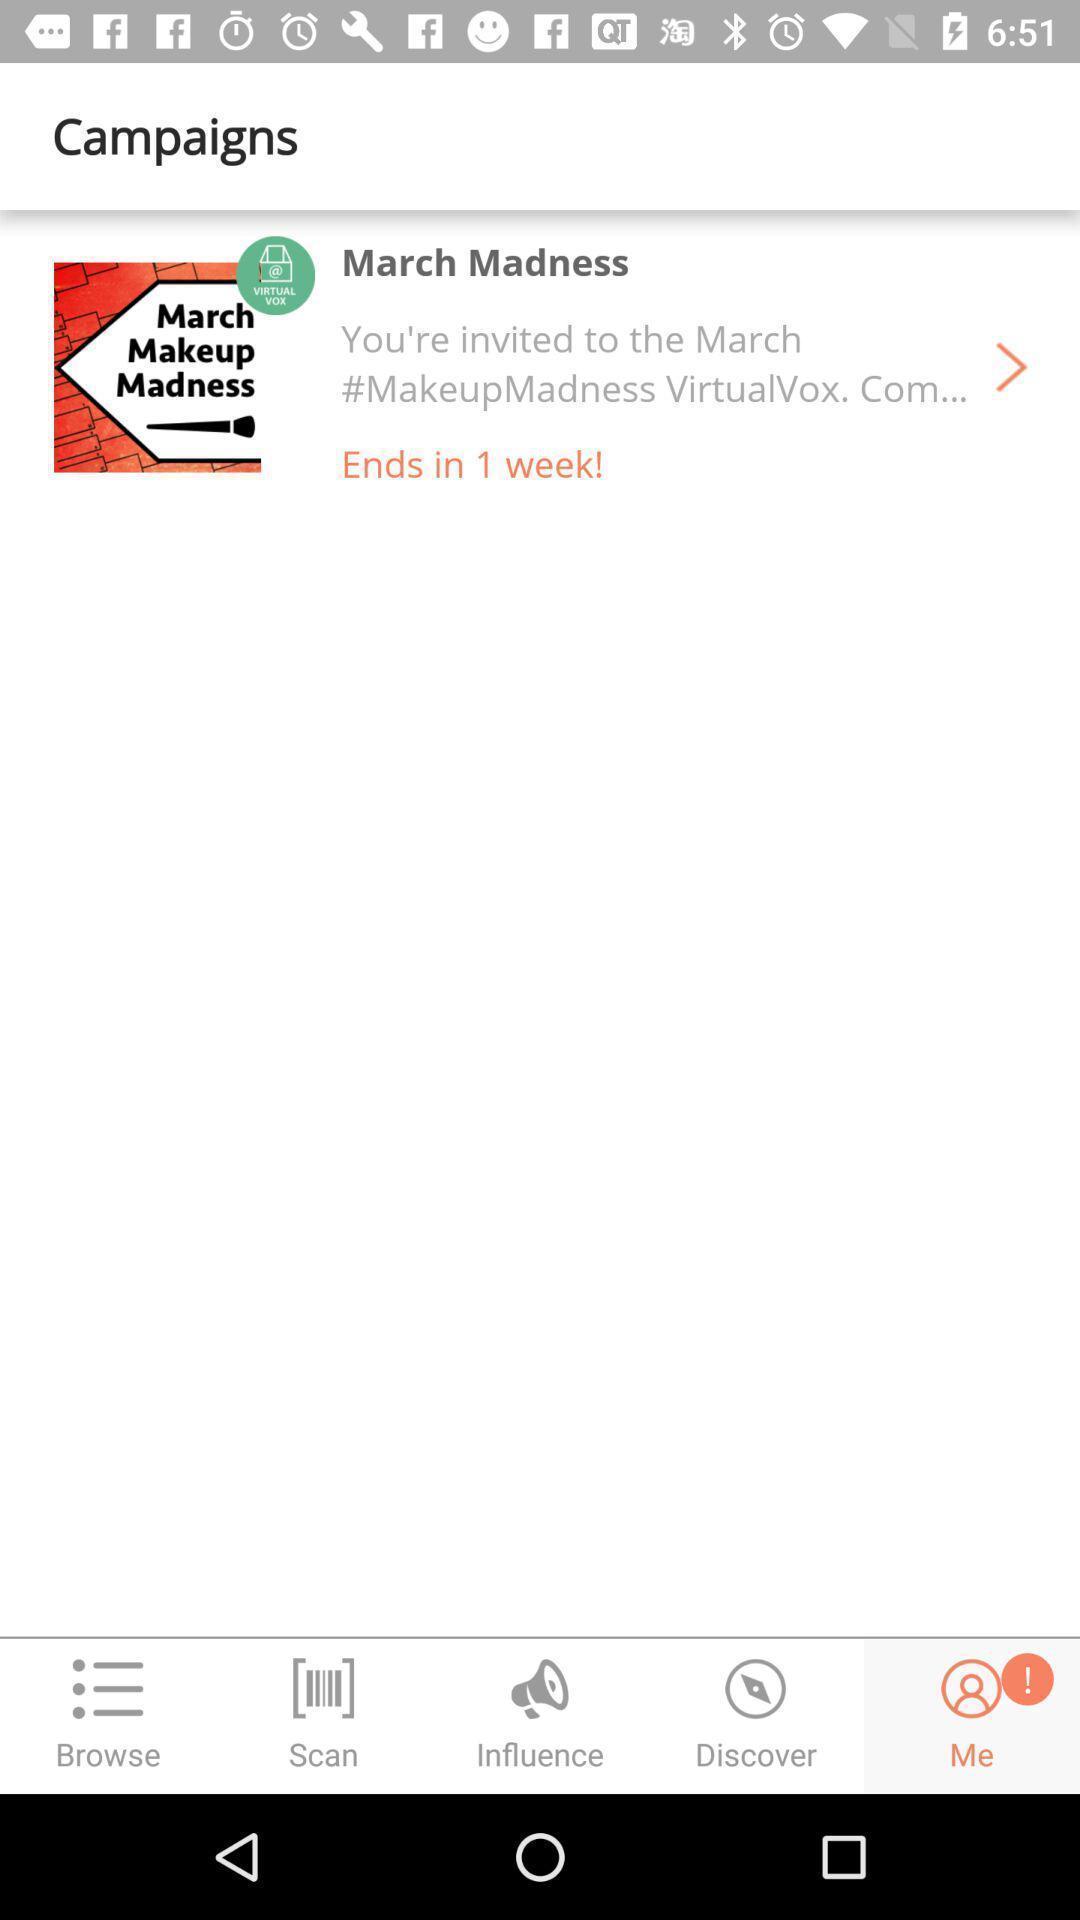Please provide a description for this image. Screen shows campaigns details in a shopping app. 